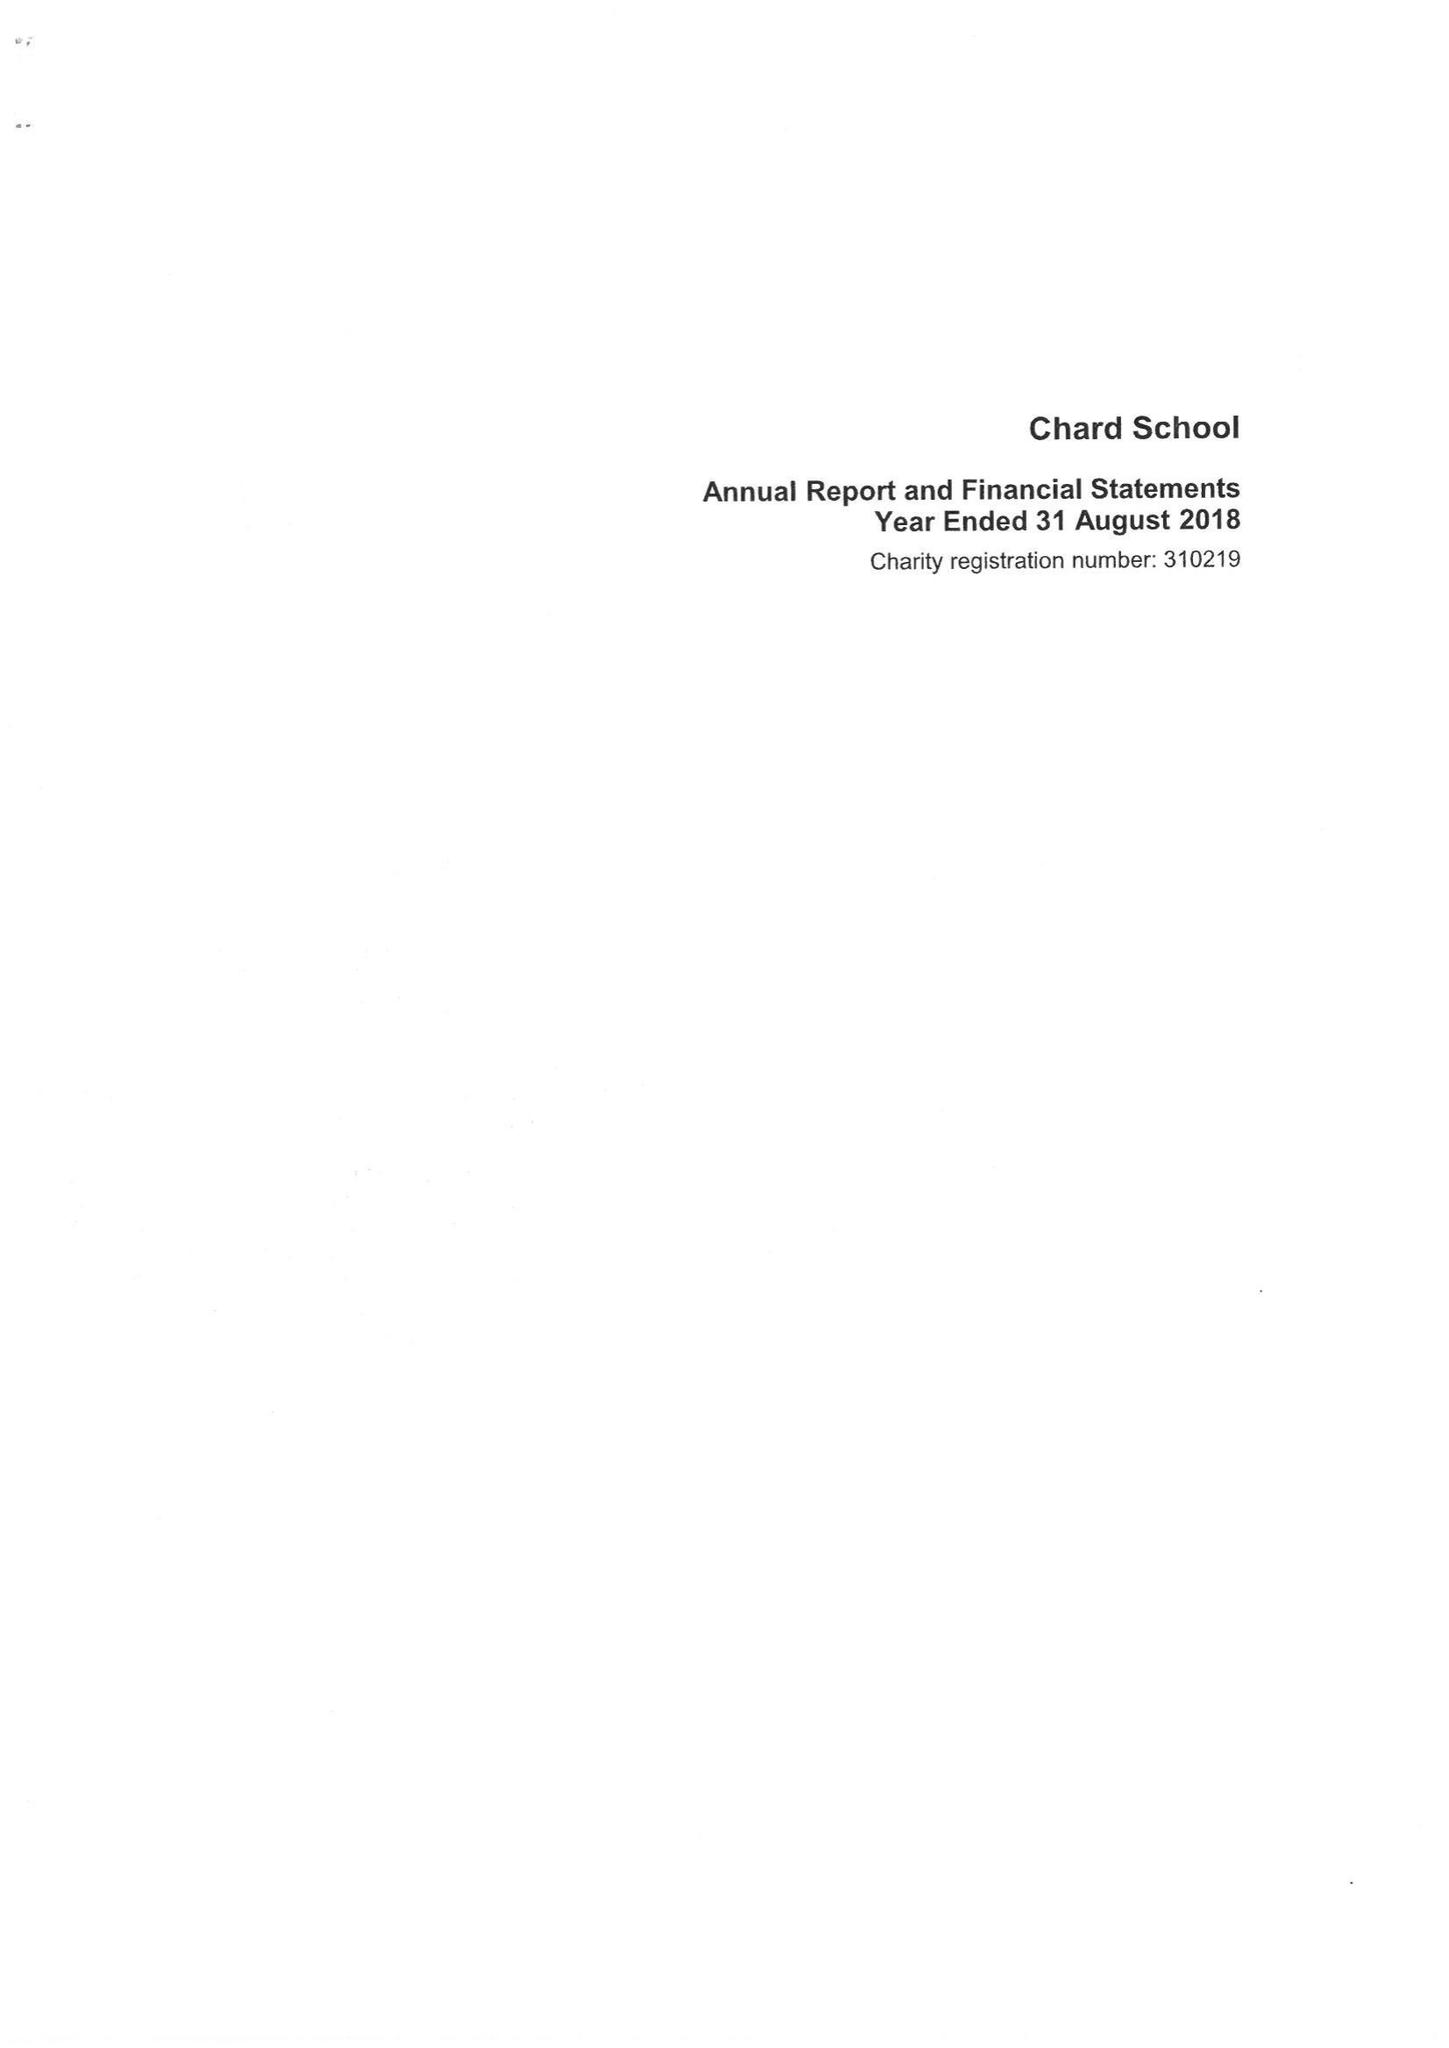What is the value for the charity_name?
Answer the question using a single word or phrase. Chard School 